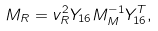Convert formula to latex. <formula><loc_0><loc_0><loc_500><loc_500>M _ { R } = v _ { R } ^ { 2 } Y _ { 1 6 } M _ { M } ^ { - 1 } Y _ { 1 6 } ^ { T } ,</formula> 